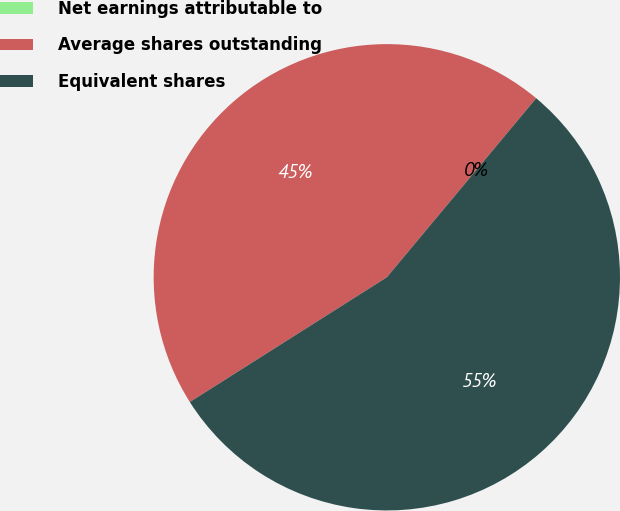Convert chart to OTSL. <chart><loc_0><loc_0><loc_500><loc_500><pie_chart><fcel>Net earnings attributable to<fcel>Average shares outstanding<fcel>Equivalent shares<nl><fcel>0.0%<fcel>45.05%<fcel>54.95%<nl></chart> 